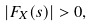<formula> <loc_0><loc_0><loc_500><loc_500>| F _ { X } ( s ) | > 0 ,</formula> 